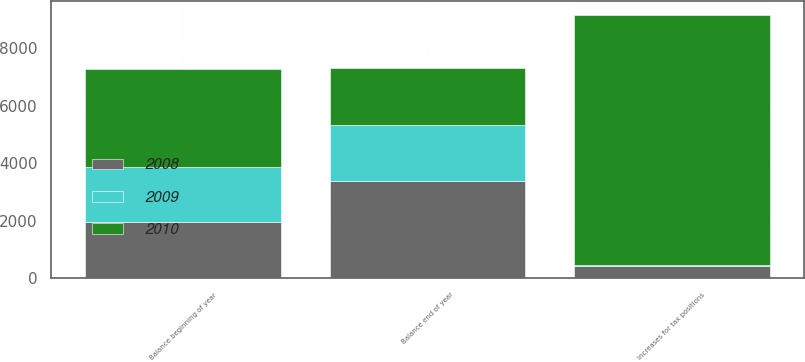Convert chart to OTSL. <chart><loc_0><loc_0><loc_500><loc_500><stacked_bar_chart><ecel><fcel>Balance beginning of year<fcel>Increases for tax positions<fcel>Balance end of year<nl><fcel>2010<fcel>3387<fcel>8696<fcel>1952<nl><fcel>2008<fcel>1952<fcel>440<fcel>3387<nl><fcel>2009<fcel>1928<fcel>24<fcel>1952<nl></chart> 